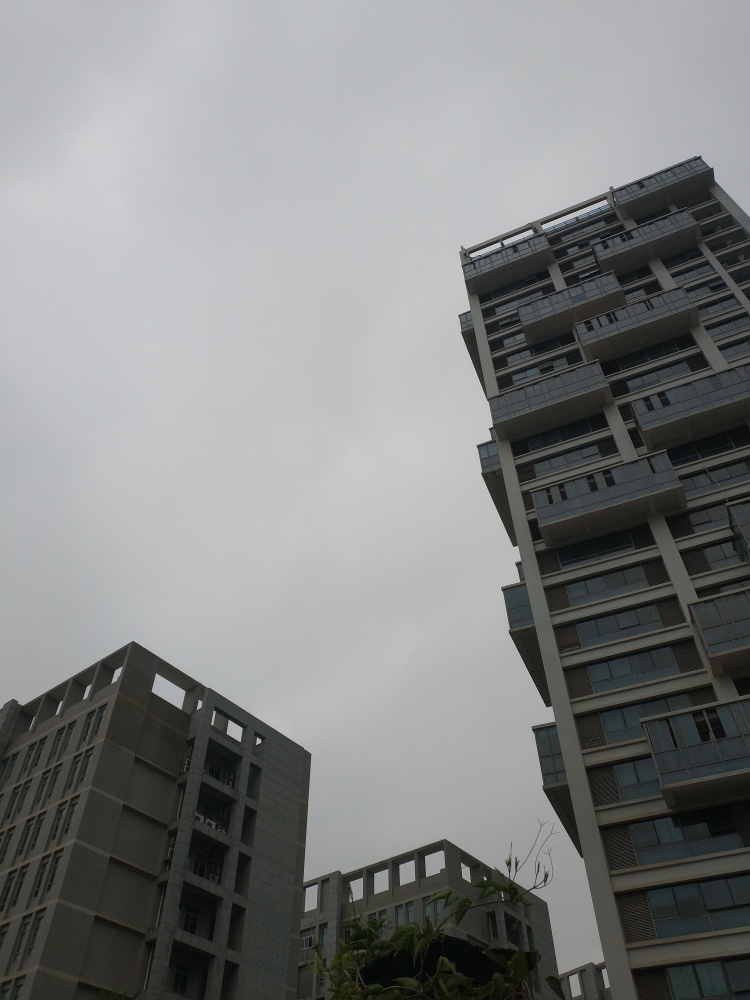Is the lighting sufficient in the image? The lighting in the image appears to be on the lower end of the spectrum due to the overcast sky, which contributes to a general sense of insufficiency in illumination. The brightness is muted, suggesting that the natural light available is limited, which may not be optimal for activities that require good lighting, such as reading outdoors. 